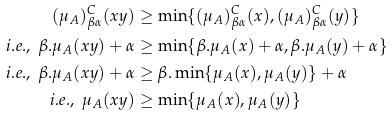Convert formula to latex. <formula><loc_0><loc_0><loc_500><loc_500>( \mu _ { A } ) _ { \beta \alpha } ^ { C } ( x y ) & \geq \min \{ ( \mu _ { A } ) _ { \beta \alpha } ^ { C } ( x ) , ( \mu _ { A } ) _ { \beta \alpha } ^ { C } ( y ) \} \\ i . e . , \ \beta . \mu _ { A } ( x y ) + \alpha & \geq \min \{ \beta . \mu _ { A } ( x ) + \alpha , \beta . \mu _ { A } ( y ) + \alpha \} \\ i . e . , \ \beta . \mu _ { A } ( x y ) + \alpha & \geq \beta . \min \{ \mu _ { A } ( x ) , \mu _ { A } ( y ) \} + \alpha \\ i . e . , \ \mu _ { A } ( x y ) & \geq \min \{ \mu _ { A } ( x ) , \mu _ { A } ( y ) \}</formula> 